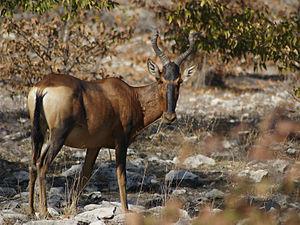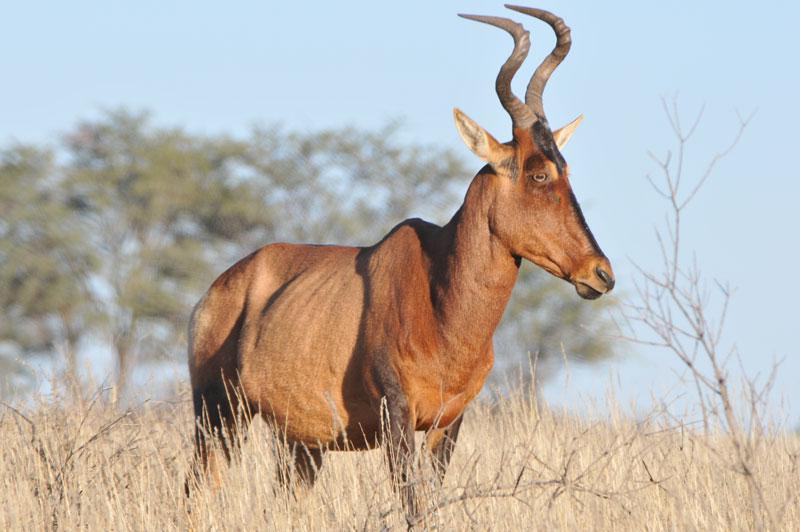The first image is the image on the left, the second image is the image on the right. Analyze the images presented: Is the assertion "Two brown horned animals positioned sideways toward the same direction are alone in a wilderness area, at least one of them showing its tail." valid? Answer yes or no. Yes. The first image is the image on the left, the second image is the image on the right. Assess this claim about the two images: "Two antelopes are facing right.". Correct or not? Answer yes or no. Yes. 